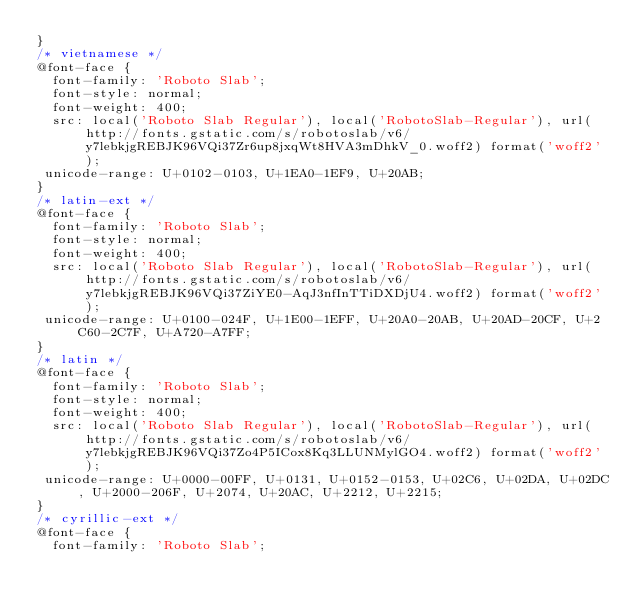<code> <loc_0><loc_0><loc_500><loc_500><_CSS_>}
/* vietnamese */
@font-face {
	font-family: 'Roboto Slab';
	font-style: normal;
	font-weight: 400;
	src: local('Roboto Slab Regular'), local('RobotoSlab-Regular'), url(http://fonts.gstatic.com/s/robotoslab/v6/y7lebkjgREBJK96VQi37Zr6up8jxqWt8HVA3mDhkV_0.woff2) format('woff2');
 unicode-range: U+0102-0103, U+1EA0-1EF9, U+20AB;
}
/* latin-ext */
@font-face {
	font-family: 'Roboto Slab';
	font-style: normal;
	font-weight: 400;
	src: local('Roboto Slab Regular'), local('RobotoSlab-Regular'), url(http://fonts.gstatic.com/s/robotoslab/v6/y7lebkjgREBJK96VQi37ZiYE0-AqJ3nfInTTiDXDjU4.woff2) format('woff2');
 unicode-range: U+0100-024F, U+1E00-1EFF, U+20A0-20AB, U+20AD-20CF, U+2C60-2C7F, U+A720-A7FF;
}
/* latin */
@font-face {
	font-family: 'Roboto Slab';
	font-style: normal;
	font-weight: 400;
	src: local('Roboto Slab Regular'), local('RobotoSlab-Regular'), url(http://fonts.gstatic.com/s/robotoslab/v6/y7lebkjgREBJK96VQi37Zo4P5ICox8Kq3LLUNMylGO4.woff2) format('woff2');
 unicode-range: U+0000-00FF, U+0131, U+0152-0153, U+02C6, U+02DA, U+02DC, U+2000-206F, U+2074, U+20AC, U+2212, U+2215;
}
/* cyrillic-ext */
@font-face {
	font-family: 'Roboto Slab';</code> 